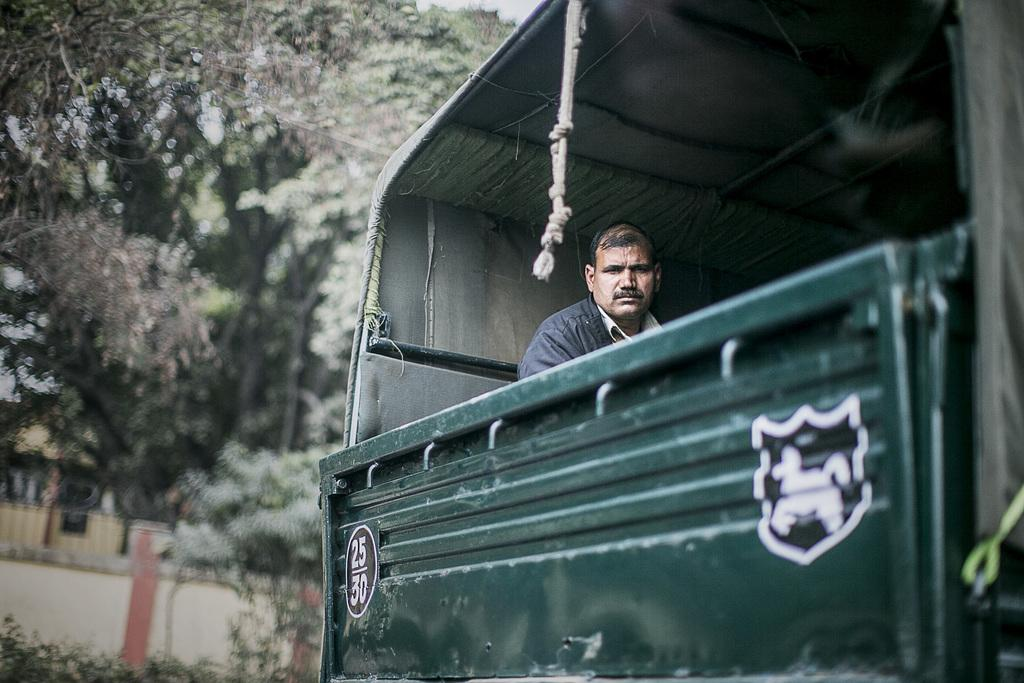What is the main subject of the image? There is a vehicle in the image. Who or what is inside the vehicle? A person is sitting in the vehicle. What type of natural environment can be seen in the image? There are trees visible in the image. What is the location of the wall in the image? There is a wall at the bottom of the image. How many fish are swimming in the glass container in the image? There is no glass container or fish present in the image. 